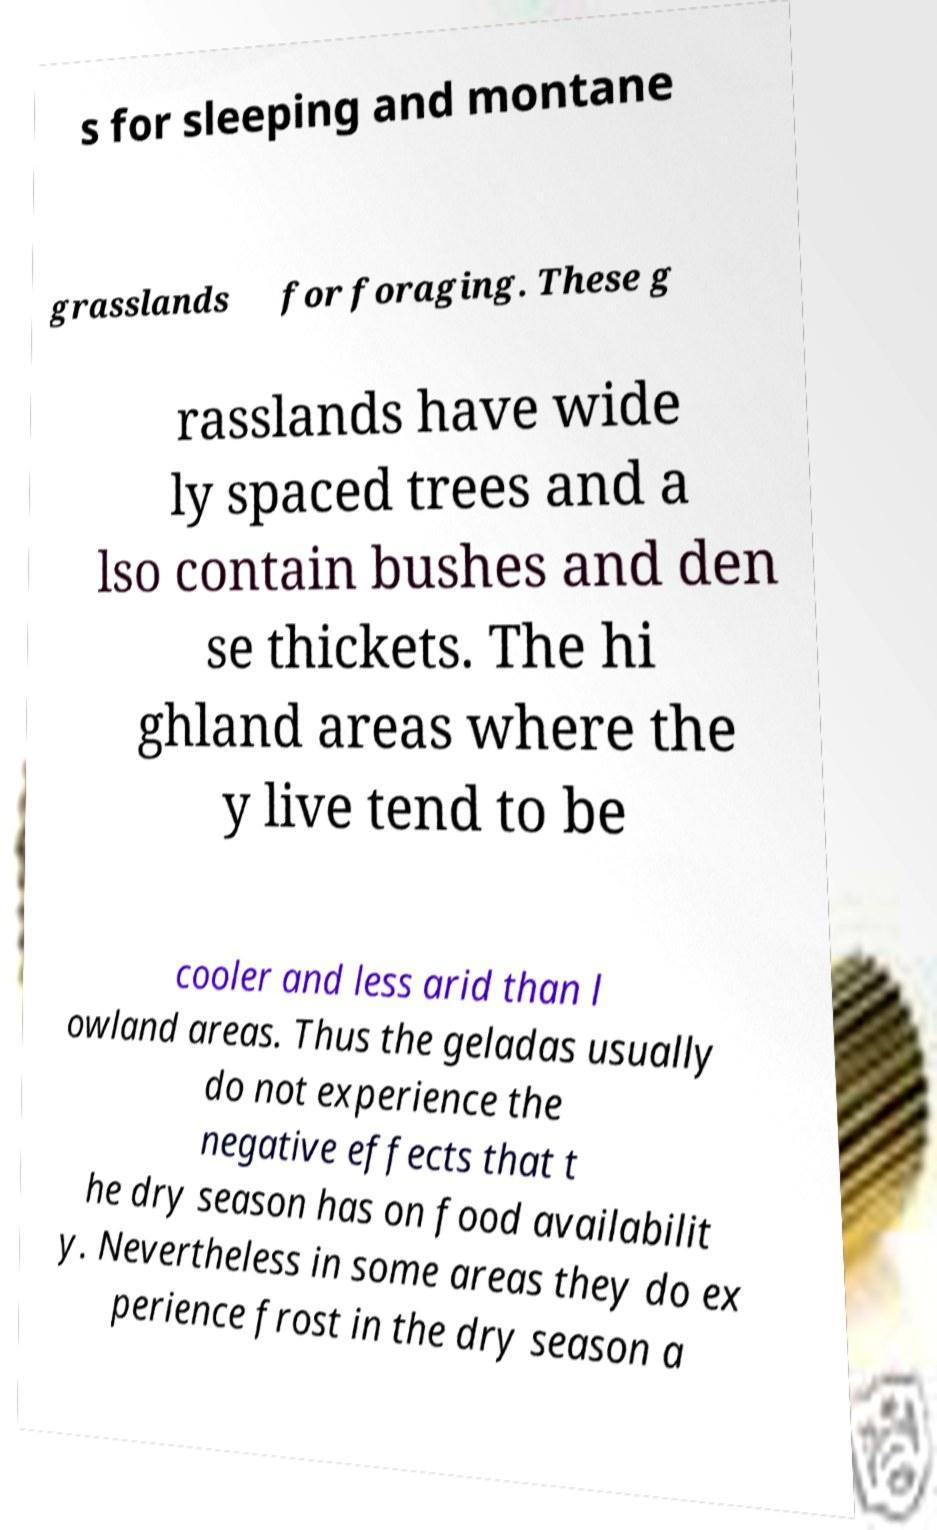What messages or text are displayed in this image? I need them in a readable, typed format. s for sleeping and montane grasslands for foraging. These g rasslands have wide ly spaced trees and a lso contain bushes and den se thickets. The hi ghland areas where the y live tend to be cooler and less arid than l owland areas. Thus the geladas usually do not experience the negative effects that t he dry season has on food availabilit y. Nevertheless in some areas they do ex perience frost in the dry season a 